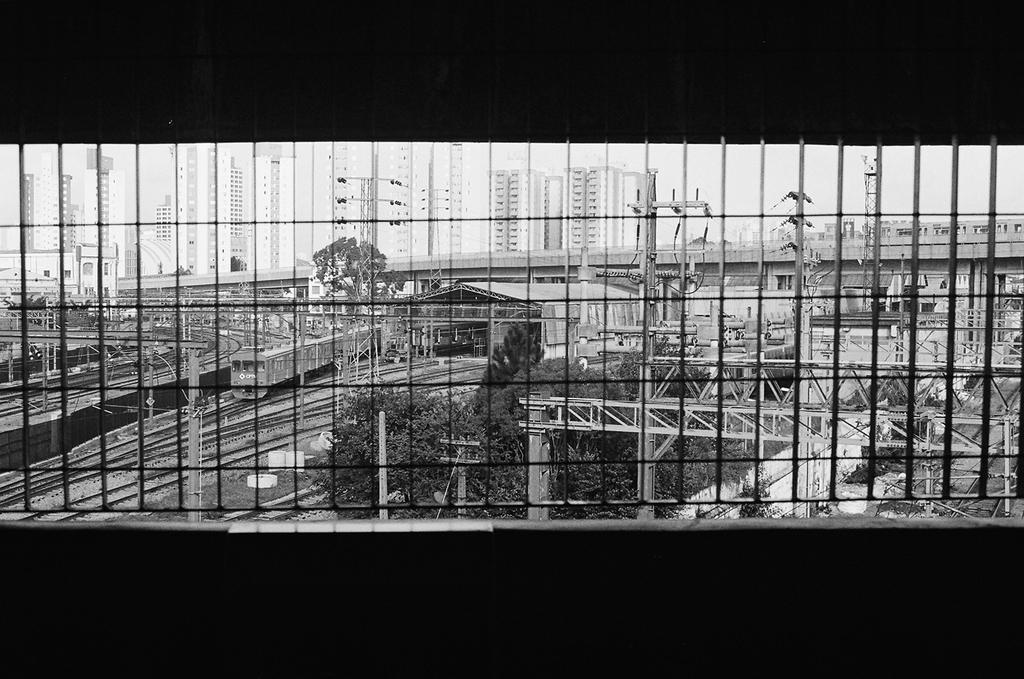Could you give a brief overview of what you see in this image? In this picture I can see the train on the railway tracks. Beside that we can see the shade. In the center` I can see the bridge. In the background I can see the trees, plants, poles, street lights, buildings, sky and other objects. At the bottom I can see the darkness. 